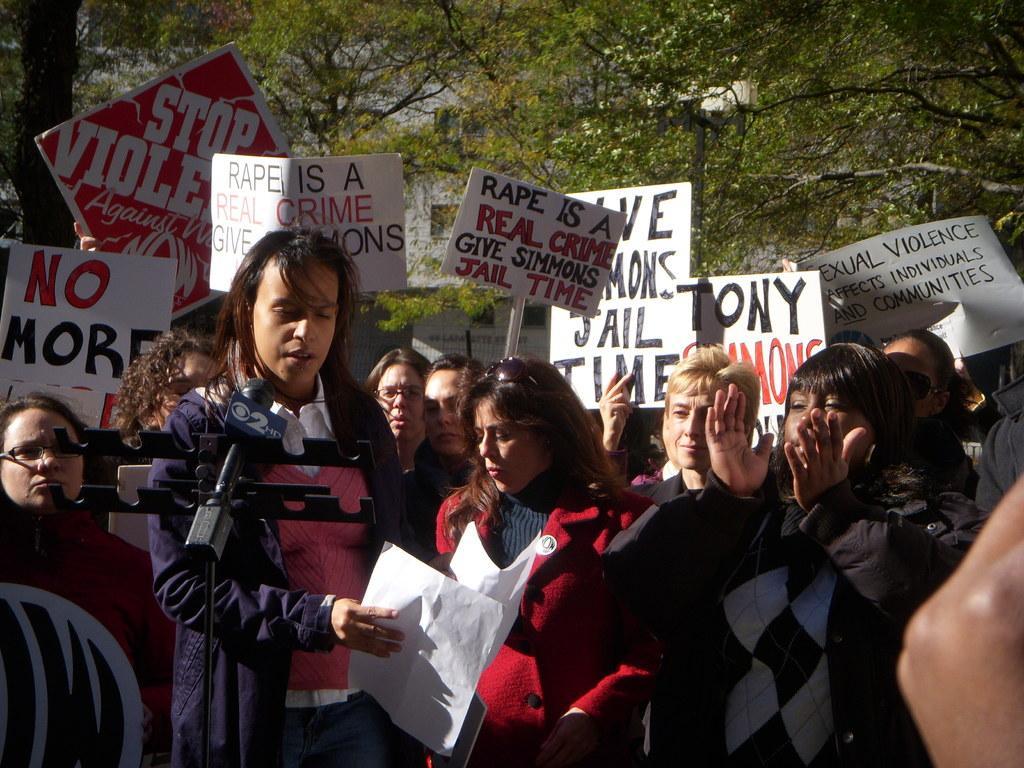In one or two sentences, can you explain what this image depicts? In this image there is a woman in the middle who is holding the paper. In front of her there is a mic. In the background there are few people who are protesting by holding the placards. Behind them there are trees. 